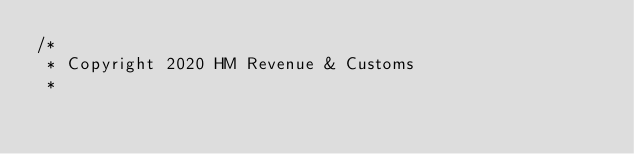<code> <loc_0><loc_0><loc_500><loc_500><_Scala_>/*
 * Copyright 2020 HM Revenue & Customs
 *</code> 